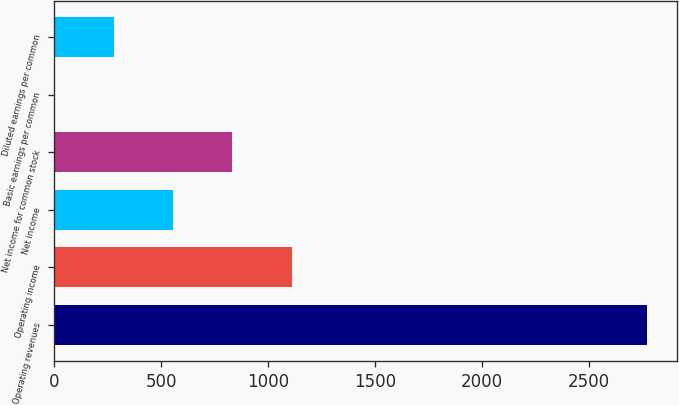<chart> <loc_0><loc_0><loc_500><loc_500><bar_chart><fcel>Operating revenues<fcel>Operating income<fcel>Net income<fcel>Net income for common stock<fcel>Basic earnings per common<fcel>Diluted earnings per common<nl><fcel>2771<fcel>1108.85<fcel>554.79<fcel>831.82<fcel>0.73<fcel>277.76<nl></chart> 